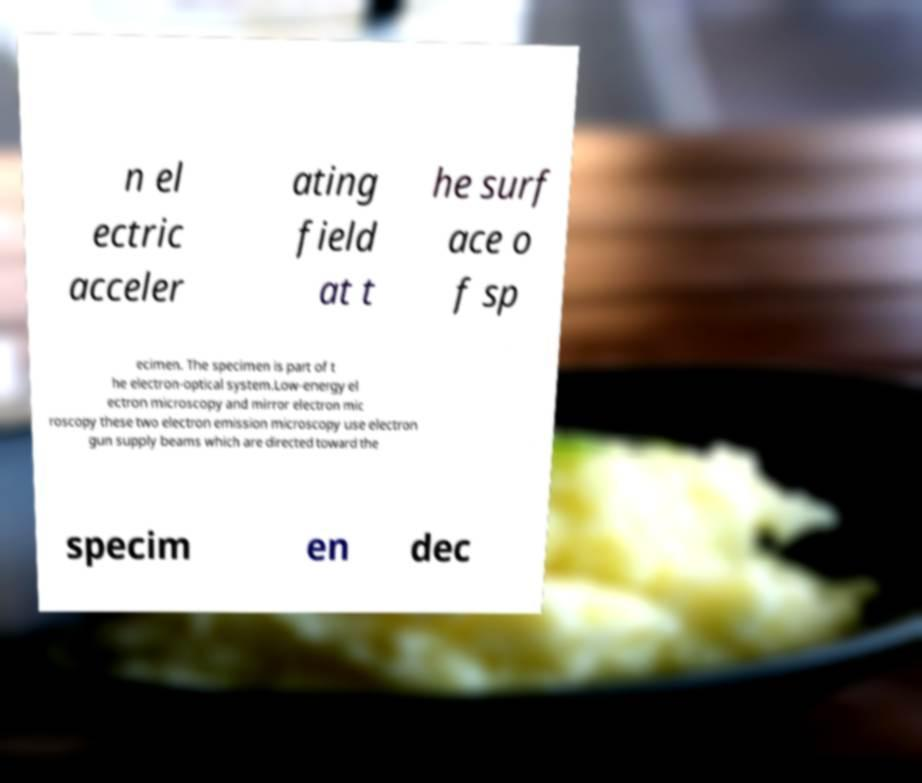What messages or text are displayed in this image? I need them in a readable, typed format. n el ectric acceler ating field at t he surf ace o f sp ecimen. The specimen is part of t he electron-optical system.Low-energy el ectron microscopy and mirror electron mic roscopy these two electron emission microscopy use electron gun supply beams which are directed toward the specim en dec 